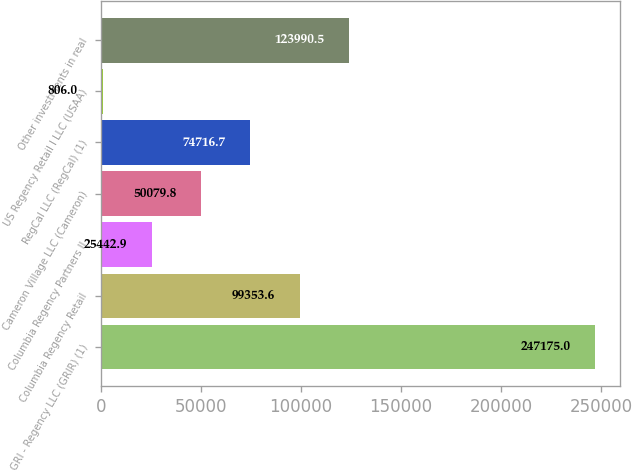Convert chart. <chart><loc_0><loc_0><loc_500><loc_500><bar_chart><fcel>GRI - Regency LLC (GRIR) (1)<fcel>Columbia Regency Retail<fcel>Columbia Regency Partners II<fcel>Cameron Village LLC (Cameron)<fcel>RegCal LLC (RegCal) (1)<fcel>US Regency Retail I LLC (USAA)<fcel>Other investments in real<nl><fcel>247175<fcel>99353.6<fcel>25442.9<fcel>50079.8<fcel>74716.7<fcel>806<fcel>123990<nl></chart> 